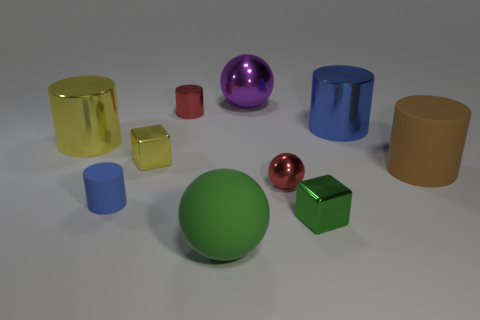What is the size of the metallic ball that is in front of the large shiny thing that is left of the small yellow metallic block to the right of the yellow shiny cylinder?
Offer a very short reply. Small. Do the tiny rubber object and the red thing that is in front of the big blue shiny thing have the same shape?
Make the answer very short. No. How many tiny metallic cubes are both to the left of the purple metal thing and right of the purple ball?
Ensure brevity in your answer.  0. How many purple objects are either tiny shiny balls or large metal things?
Make the answer very short. 1. Is the color of the small cylinder in front of the blue metal cylinder the same as the large metallic cylinder that is on the right side of the tiny rubber object?
Keep it short and to the point. Yes. There is a small metallic cube that is to the left of the green thing on the right side of the large shiny object behind the red cylinder; what is its color?
Provide a short and direct response. Yellow. There is a big ball behind the large brown rubber cylinder; is there a metallic cube that is in front of it?
Your response must be concise. Yes. There is a tiny red object on the left side of the big green matte object; does it have the same shape as the large yellow metal thing?
Provide a short and direct response. Yes. How many balls are either big blue objects or big yellow objects?
Ensure brevity in your answer.  0. What number of blue metallic things are there?
Keep it short and to the point. 1. 